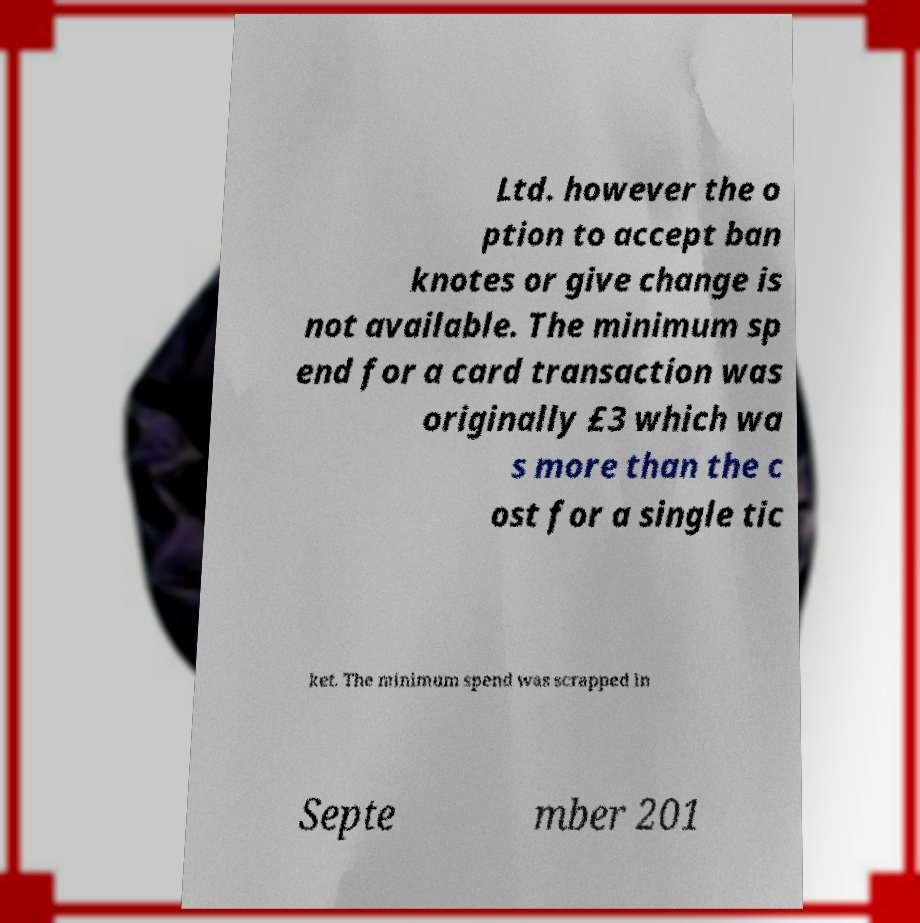Can you read and provide the text displayed in the image?This photo seems to have some interesting text. Can you extract and type it out for me? Ltd. however the o ption to accept ban knotes or give change is not available. The minimum sp end for a card transaction was originally £3 which wa s more than the c ost for a single tic ket. The minimum spend was scrapped in Septe mber 201 